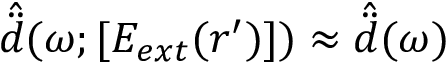<formula> <loc_0><loc_0><loc_500><loc_500>\hat { \ddot { d } } ( \omega ; [ E _ { e x t } ( r ^ { \prime } ) ] ) \approx \hat { \ddot { d } } ( \omega )</formula> 